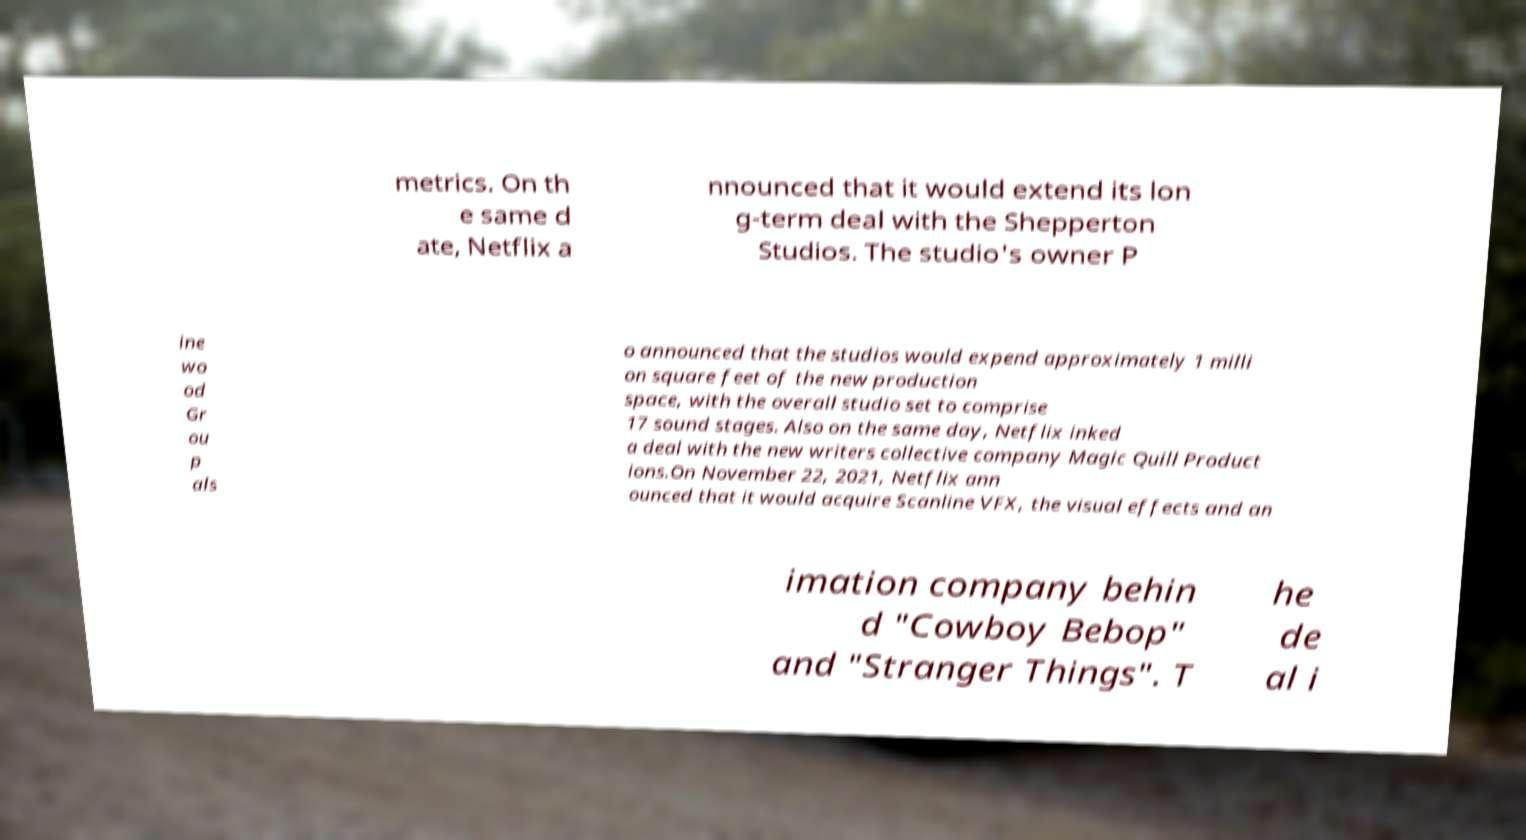There's text embedded in this image that I need extracted. Can you transcribe it verbatim? metrics. On th e same d ate, Netflix a nnounced that it would extend its lon g-term deal with the Shepperton Studios. The studio's owner P ine wo od Gr ou p als o announced that the studios would expend approximately 1 milli on square feet of the new production space, with the overall studio set to comprise 17 sound stages. Also on the same day, Netflix inked a deal with the new writers collective company Magic Quill Product ions.On November 22, 2021, Netflix ann ounced that it would acquire Scanline VFX, the visual effects and an imation company behin d "Cowboy Bebop" and "Stranger Things". T he de al i 